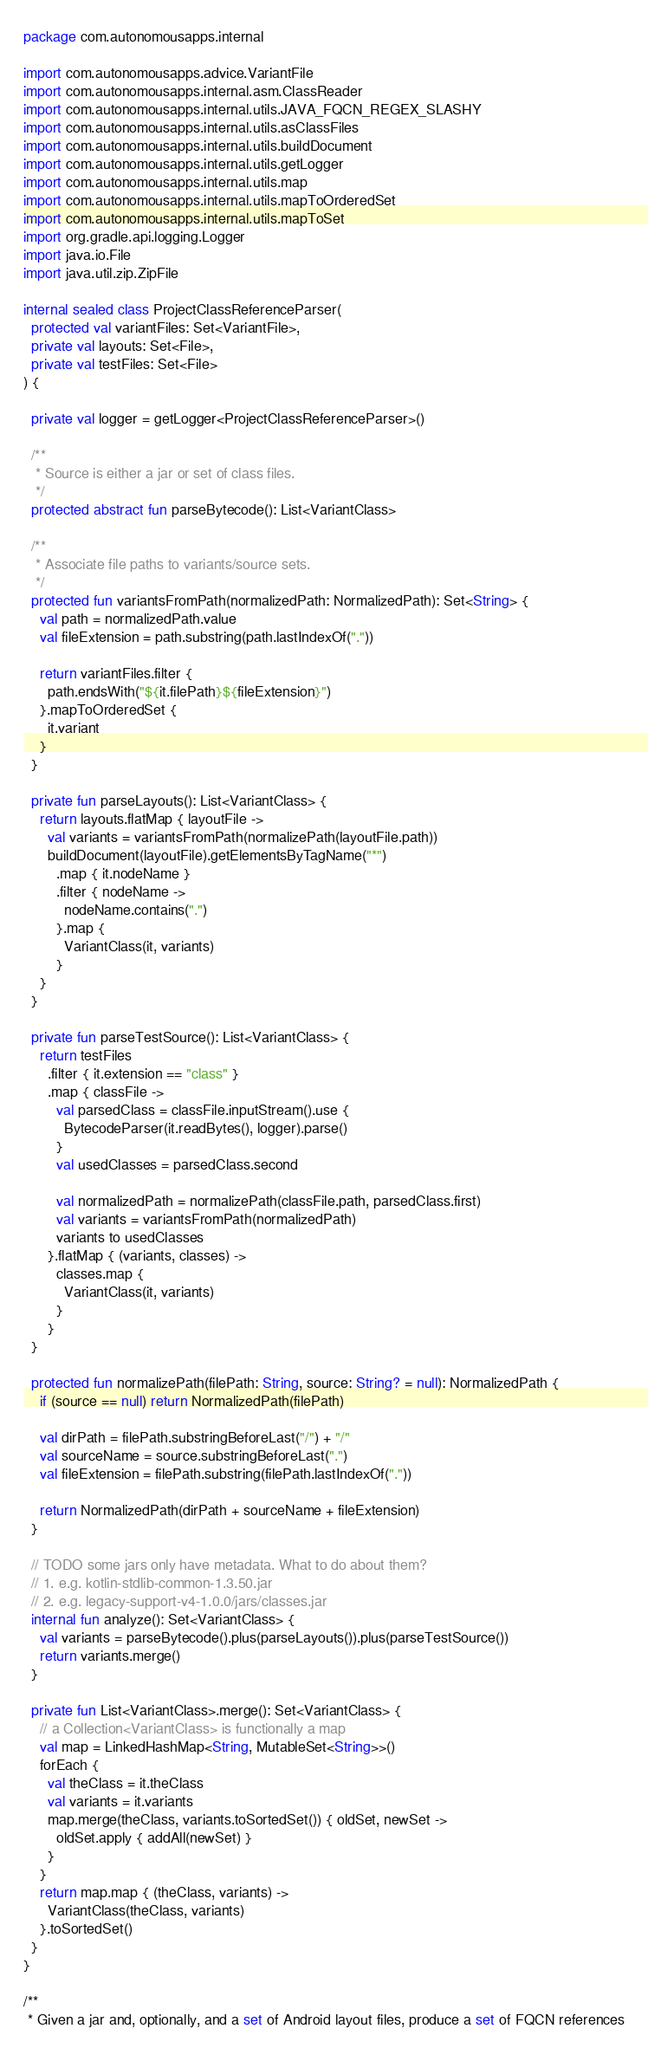<code> <loc_0><loc_0><loc_500><loc_500><_Kotlin_>package com.autonomousapps.internal

import com.autonomousapps.advice.VariantFile
import com.autonomousapps.internal.asm.ClassReader
import com.autonomousapps.internal.utils.JAVA_FQCN_REGEX_SLASHY
import com.autonomousapps.internal.utils.asClassFiles
import com.autonomousapps.internal.utils.buildDocument
import com.autonomousapps.internal.utils.getLogger
import com.autonomousapps.internal.utils.map
import com.autonomousapps.internal.utils.mapToOrderedSet
import com.autonomousapps.internal.utils.mapToSet
import org.gradle.api.logging.Logger
import java.io.File
import java.util.zip.ZipFile

internal sealed class ProjectClassReferenceParser(
  protected val variantFiles: Set<VariantFile>,
  private val layouts: Set<File>,
  private val testFiles: Set<File>
) {

  private val logger = getLogger<ProjectClassReferenceParser>()

  /**
   * Source is either a jar or set of class files.
   */
  protected abstract fun parseBytecode(): List<VariantClass>

  /**
   * Associate file paths to variants/source sets.
   */
  protected fun variantsFromPath(normalizedPath: NormalizedPath): Set<String> {
    val path = normalizedPath.value
    val fileExtension = path.substring(path.lastIndexOf("."))

    return variantFiles.filter {
      path.endsWith("${it.filePath}${fileExtension}")
    }.mapToOrderedSet {
      it.variant
    }
  }

  private fun parseLayouts(): List<VariantClass> {
    return layouts.flatMap { layoutFile ->
      val variants = variantsFromPath(normalizePath(layoutFile.path))
      buildDocument(layoutFile).getElementsByTagName("*")
        .map { it.nodeName }
        .filter { nodeName ->
          nodeName.contains(".")
        }.map {
          VariantClass(it, variants)
        }
    }
  }

  private fun parseTestSource(): List<VariantClass> {
    return testFiles
      .filter { it.extension == "class" }
      .map { classFile ->
        val parsedClass = classFile.inputStream().use {
          BytecodeParser(it.readBytes(), logger).parse()
        }
        val usedClasses = parsedClass.second

        val normalizedPath = normalizePath(classFile.path, parsedClass.first)
        val variants = variantsFromPath(normalizedPath)
        variants to usedClasses
      }.flatMap { (variants, classes) ->
        classes.map {
          VariantClass(it, variants)
        }
      }
  }

  protected fun normalizePath(filePath: String, source: String? = null): NormalizedPath {
    if (source == null) return NormalizedPath(filePath)

    val dirPath = filePath.substringBeforeLast("/") + "/"
    val sourceName = source.substringBeforeLast(".")
    val fileExtension = filePath.substring(filePath.lastIndexOf("."))

    return NormalizedPath(dirPath + sourceName + fileExtension)
  }

  // TODO some jars only have metadata. What to do about them?
  // 1. e.g. kotlin-stdlib-common-1.3.50.jar
  // 2. e.g. legacy-support-v4-1.0.0/jars/classes.jar
  internal fun analyze(): Set<VariantClass> {
    val variants = parseBytecode().plus(parseLayouts()).plus(parseTestSource())
    return variants.merge()
  }

  private fun List<VariantClass>.merge(): Set<VariantClass> {
    // a Collection<VariantClass> is functionally a map
    val map = LinkedHashMap<String, MutableSet<String>>()
    forEach {
      val theClass = it.theClass
      val variants = it.variants
      map.merge(theClass, variants.toSortedSet()) { oldSet, newSet ->
        oldSet.apply { addAll(newSet) }
      }
    }
    return map.map { (theClass, variants) ->
      VariantClass(theClass, variants)
    }.toSortedSet()
  }
}

/**
 * Given a jar and, optionally, and a set of Android layout files, produce a set of FQCN references</code> 